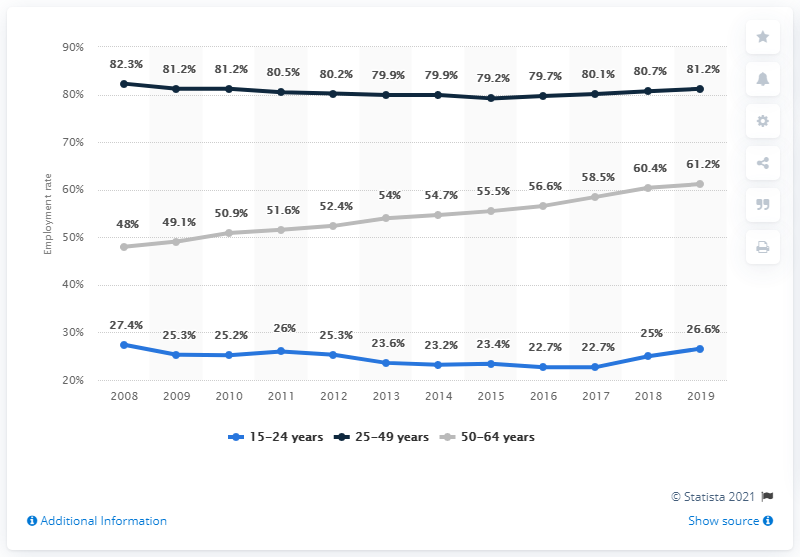Indicate a few pertinent items in this graphic. The phrase "What does the gray indicate? 50-64 years.." is a question asking for an explanation of a piece of text or data represented by a gray bar chart. According to the data from 2019, the average employment rate was 56.33%. 